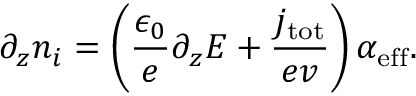Convert formula to latex. <formula><loc_0><loc_0><loc_500><loc_500>\partial _ { z } n _ { i } = \left ( \frac { \epsilon _ { 0 } } { e } \partial _ { z } E + \frac { j _ { t o t } } { e v } \right ) \alpha _ { e f f } .</formula> 